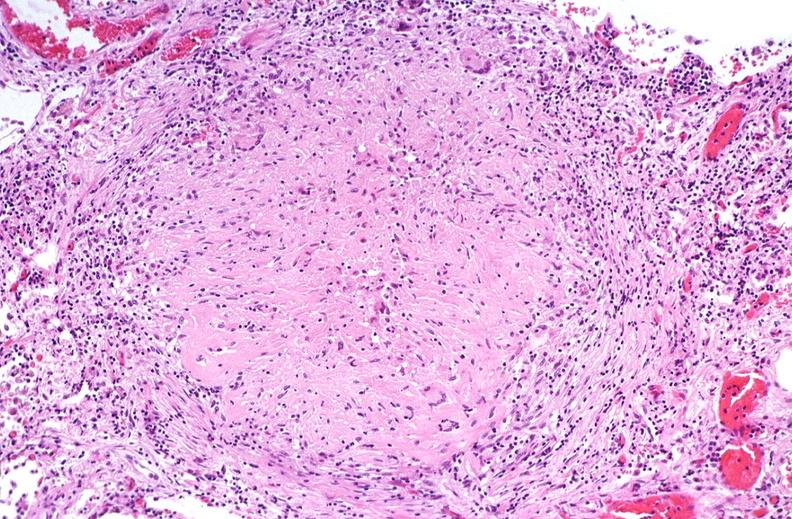what does this image show?
Answer the question using a single word or phrase. Lung 